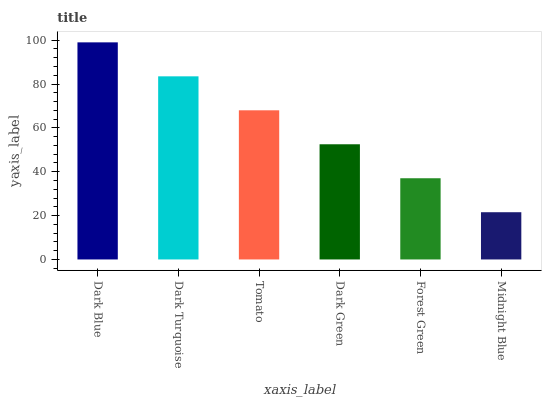Is Midnight Blue the minimum?
Answer yes or no. Yes. Is Dark Blue the maximum?
Answer yes or no. Yes. Is Dark Turquoise the minimum?
Answer yes or no. No. Is Dark Turquoise the maximum?
Answer yes or no. No. Is Dark Blue greater than Dark Turquoise?
Answer yes or no. Yes. Is Dark Turquoise less than Dark Blue?
Answer yes or no. Yes. Is Dark Turquoise greater than Dark Blue?
Answer yes or no. No. Is Dark Blue less than Dark Turquoise?
Answer yes or no. No. Is Tomato the high median?
Answer yes or no. Yes. Is Dark Green the low median?
Answer yes or no. Yes. Is Dark Turquoise the high median?
Answer yes or no. No. Is Dark Blue the low median?
Answer yes or no. No. 